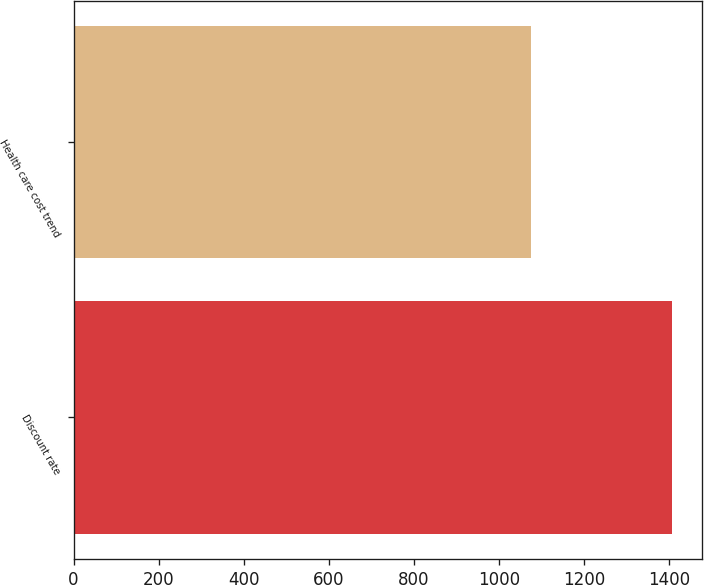Convert chart. <chart><loc_0><loc_0><loc_500><loc_500><bar_chart><fcel>Discount rate<fcel>Health care cost trend<nl><fcel>1406<fcel>1074<nl></chart> 